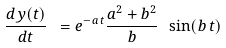<formula> <loc_0><loc_0><loc_500><loc_500>\frac { d y ( t ) } { d t } \ = e ^ { - a \, t } \frac { a ^ { 2 } + b ^ { 2 } } { b } \ \sin ( b \, t )</formula> 